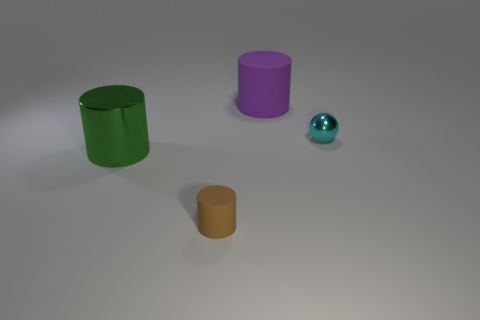How many other objects are there of the same size as the cyan metallic object?
Give a very brief answer. 1. There is a metal object that is behind the metallic cylinder in front of the large cylinder behind the small metallic sphere; what is its size?
Offer a very short reply. Small. There is a thing that is both right of the small brown object and in front of the large matte object; how big is it?
Offer a very short reply. Small. There is a big cylinder right of the large metallic cylinder; does it have the same color as the shiny object behind the green metallic thing?
Offer a terse response. No. How many big green metallic cylinders are behind the large purple rubber cylinder?
Provide a short and direct response. 0. Are there any large matte cylinders that are in front of the big object that is behind the big object that is in front of the ball?
Your answer should be compact. No. What number of brown cylinders have the same size as the ball?
Make the answer very short. 1. What is the material of the small object that is on the left side of the matte cylinder on the right side of the brown object?
Make the answer very short. Rubber. What shape is the shiny thing to the right of the large thing to the left of the big thing behind the tiny metallic sphere?
Your answer should be compact. Sphere. There is a small object that is on the right side of the large purple thing; is it the same shape as the matte object that is behind the big green cylinder?
Your answer should be very brief. No. 